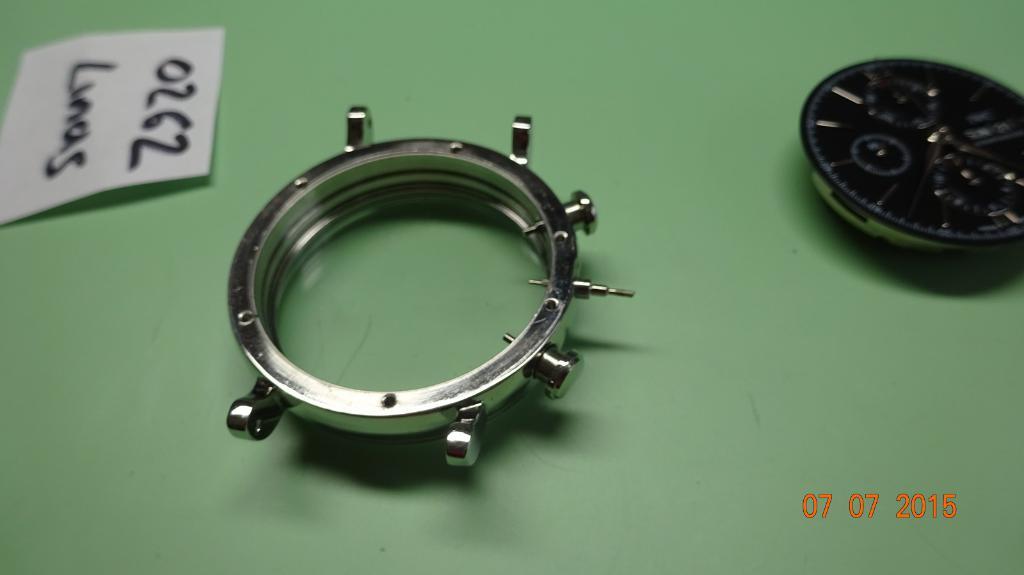What date was the photo taken?
Offer a very short reply. 07 07 2015. 